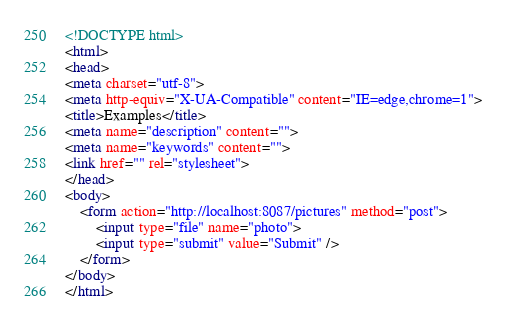<code> <loc_0><loc_0><loc_500><loc_500><_HTML_><!DOCTYPE html>
<html>
<head>
<meta charset="utf-8">
<meta http-equiv="X-UA-Compatible" content="IE=edge,chrome=1">
<title>Examples</title>
<meta name="description" content="">
<meta name="keywords" content="">
<link href="" rel="stylesheet">
</head>
<body>
    <form action="http://localhost:8087/pictures" method="post">
    	<input type="file" name="photo">
    	<input type="submit" value="Submit" />
    </form>
</body>
</html></code> 